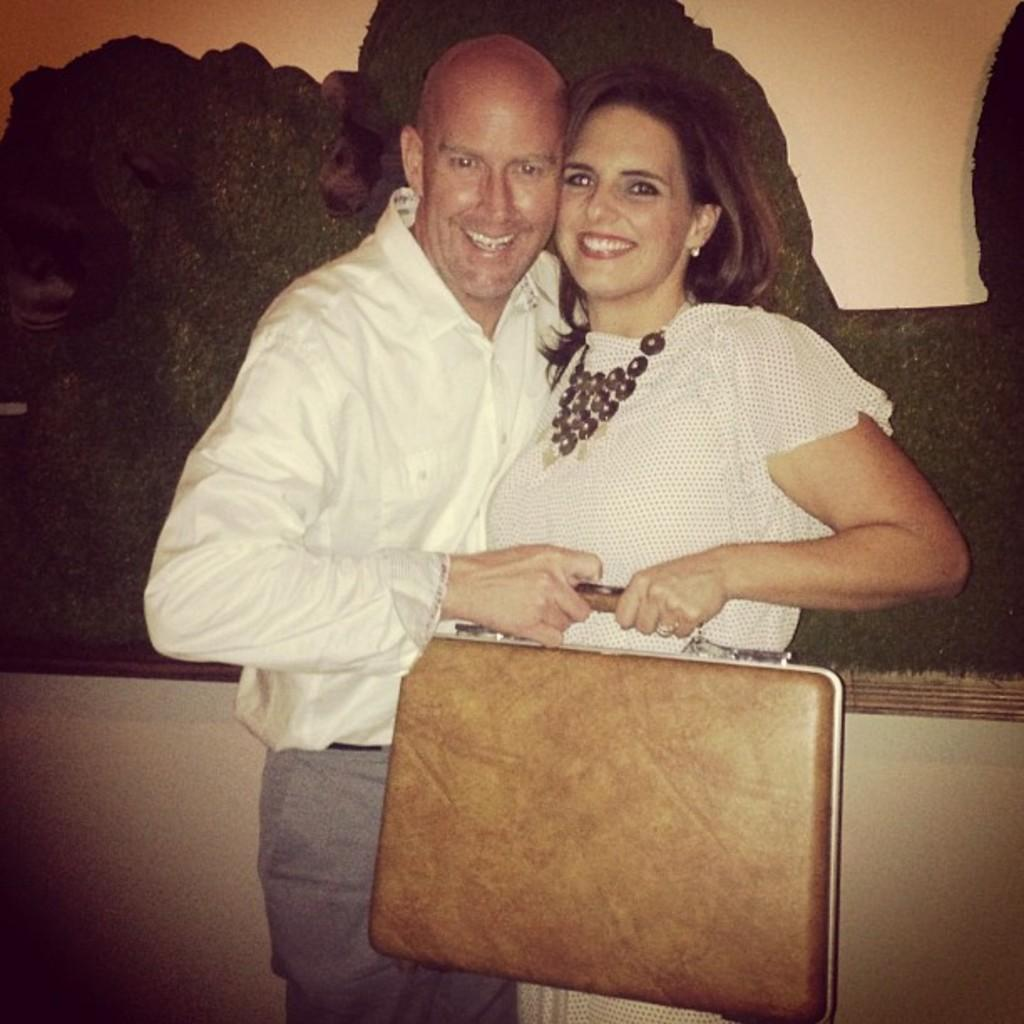Who is present in the image? There is a man and a woman in the image. What are the man and woman holding? The man and woman are holding a suitcase. What is the facial expression of the man and woman? The man and woman are smiling. What type of plantation can be seen in the background of the image? There is no plantation present in the image; it only features a man and a woman holding a suitcase and smiling. 